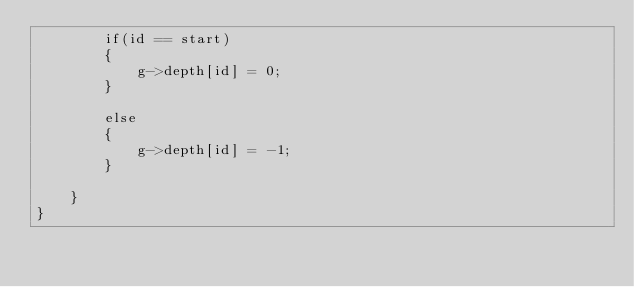Convert code to text. <code><loc_0><loc_0><loc_500><loc_500><_Cuda_>        if(id == start)
        {
            g->depth[id] = 0;
        }

        else
        {
            g->depth[id] = -1;
        }

    }
}</code> 